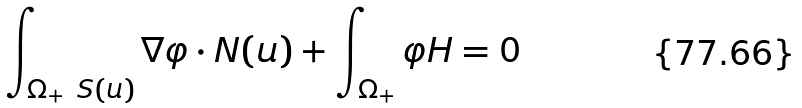Convert formula to latex. <formula><loc_0><loc_0><loc_500><loc_500>\int _ { \Omega _ { + } \ S ( u ) } \nabla \varphi \cdot N ( u ) + \int _ { \Omega _ { + } } \varphi H = 0</formula> 